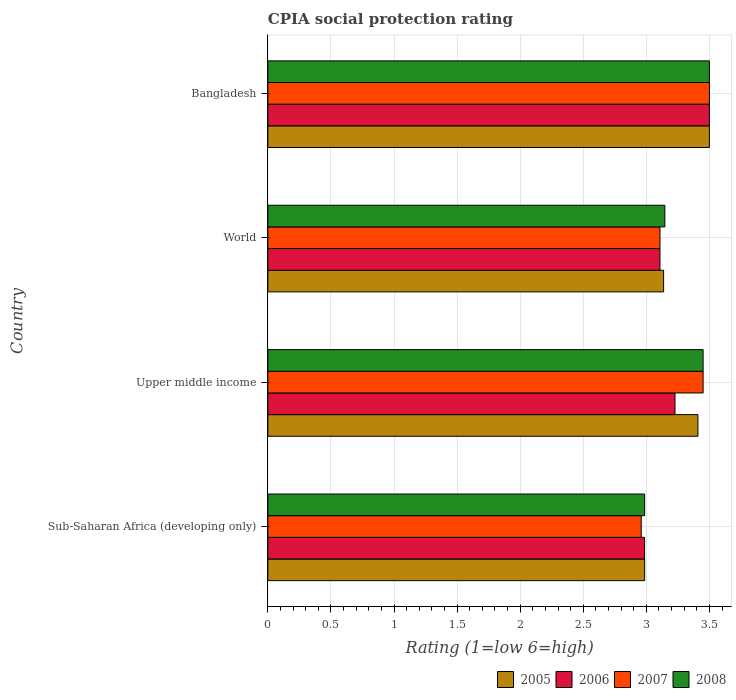How many groups of bars are there?
Provide a succinct answer. 4. Are the number of bars on each tick of the Y-axis equal?
Ensure brevity in your answer.  Yes. What is the label of the 3rd group of bars from the top?
Give a very brief answer. Upper middle income. In how many cases, is the number of bars for a given country not equal to the number of legend labels?
Your answer should be compact. 0. What is the CPIA rating in 2005 in Bangladesh?
Ensure brevity in your answer.  3.5. Across all countries, what is the maximum CPIA rating in 2007?
Your answer should be compact. 3.5. Across all countries, what is the minimum CPIA rating in 2007?
Offer a terse response. 2.96. In which country was the CPIA rating in 2005 minimum?
Give a very brief answer. Sub-Saharan Africa (developing only). What is the total CPIA rating in 2005 in the graph?
Keep it short and to the point. 13.03. What is the difference between the CPIA rating in 2008 in Bangladesh and that in World?
Your answer should be compact. 0.35. What is the difference between the CPIA rating in 2005 in World and the CPIA rating in 2008 in Upper middle income?
Make the answer very short. -0.31. What is the average CPIA rating in 2008 per country?
Offer a very short reply. 3.27. What is the difference between the CPIA rating in 2007 and CPIA rating in 2006 in Upper middle income?
Offer a very short reply. 0.22. What is the ratio of the CPIA rating in 2008 in Bangladesh to that in Upper middle income?
Offer a very short reply. 1.01. Is the CPIA rating in 2008 in Bangladesh less than that in World?
Offer a terse response. No. Is the difference between the CPIA rating in 2007 in Sub-Saharan Africa (developing only) and World greater than the difference between the CPIA rating in 2006 in Sub-Saharan Africa (developing only) and World?
Give a very brief answer. No. What is the difference between the highest and the second highest CPIA rating in 2007?
Your answer should be compact. 0.05. What is the difference between the highest and the lowest CPIA rating in 2005?
Provide a short and direct response. 0.51. Is the sum of the CPIA rating in 2008 in Bangladesh and Upper middle income greater than the maximum CPIA rating in 2006 across all countries?
Offer a very short reply. Yes. Is it the case that in every country, the sum of the CPIA rating in 2005 and CPIA rating in 2006 is greater than the CPIA rating in 2007?
Offer a terse response. Yes. How many bars are there?
Your answer should be very brief. 16. Are all the bars in the graph horizontal?
Ensure brevity in your answer.  Yes. How many countries are there in the graph?
Keep it short and to the point. 4. Does the graph contain grids?
Your answer should be very brief. Yes. Where does the legend appear in the graph?
Keep it short and to the point. Bottom right. How are the legend labels stacked?
Your answer should be compact. Horizontal. What is the title of the graph?
Your answer should be compact. CPIA social protection rating. Does "1997" appear as one of the legend labels in the graph?
Ensure brevity in your answer.  No. What is the Rating (1=low 6=high) in 2005 in Sub-Saharan Africa (developing only)?
Give a very brief answer. 2.99. What is the Rating (1=low 6=high) in 2006 in Sub-Saharan Africa (developing only)?
Keep it short and to the point. 2.99. What is the Rating (1=low 6=high) in 2007 in Sub-Saharan Africa (developing only)?
Offer a very short reply. 2.96. What is the Rating (1=low 6=high) of 2008 in Sub-Saharan Africa (developing only)?
Your answer should be compact. 2.99. What is the Rating (1=low 6=high) in 2005 in Upper middle income?
Ensure brevity in your answer.  3.41. What is the Rating (1=low 6=high) in 2006 in Upper middle income?
Your response must be concise. 3.23. What is the Rating (1=low 6=high) of 2007 in Upper middle income?
Your response must be concise. 3.45. What is the Rating (1=low 6=high) of 2008 in Upper middle income?
Your response must be concise. 3.45. What is the Rating (1=low 6=high) in 2005 in World?
Your response must be concise. 3.14. What is the Rating (1=low 6=high) of 2006 in World?
Keep it short and to the point. 3.11. What is the Rating (1=low 6=high) in 2007 in World?
Make the answer very short. 3.11. What is the Rating (1=low 6=high) in 2008 in World?
Your answer should be compact. 3.15. What is the Rating (1=low 6=high) in 2007 in Bangladesh?
Offer a very short reply. 3.5. What is the Rating (1=low 6=high) in 2008 in Bangladesh?
Give a very brief answer. 3.5. Across all countries, what is the maximum Rating (1=low 6=high) in 2006?
Make the answer very short. 3.5. Across all countries, what is the maximum Rating (1=low 6=high) of 2008?
Provide a succinct answer. 3.5. Across all countries, what is the minimum Rating (1=low 6=high) in 2005?
Your response must be concise. 2.99. Across all countries, what is the minimum Rating (1=low 6=high) in 2006?
Offer a terse response. 2.99. Across all countries, what is the minimum Rating (1=low 6=high) in 2007?
Offer a terse response. 2.96. Across all countries, what is the minimum Rating (1=low 6=high) in 2008?
Offer a very short reply. 2.99. What is the total Rating (1=low 6=high) of 2005 in the graph?
Your answer should be very brief. 13.03. What is the total Rating (1=low 6=high) in 2006 in the graph?
Ensure brevity in your answer.  12.82. What is the total Rating (1=low 6=high) in 2007 in the graph?
Ensure brevity in your answer.  13.02. What is the total Rating (1=low 6=high) in 2008 in the graph?
Offer a terse response. 13.08. What is the difference between the Rating (1=low 6=high) of 2005 in Sub-Saharan Africa (developing only) and that in Upper middle income?
Ensure brevity in your answer.  -0.42. What is the difference between the Rating (1=low 6=high) of 2006 in Sub-Saharan Africa (developing only) and that in Upper middle income?
Provide a succinct answer. -0.24. What is the difference between the Rating (1=low 6=high) of 2007 in Sub-Saharan Africa (developing only) and that in Upper middle income?
Your answer should be very brief. -0.49. What is the difference between the Rating (1=low 6=high) in 2008 in Sub-Saharan Africa (developing only) and that in Upper middle income?
Ensure brevity in your answer.  -0.46. What is the difference between the Rating (1=low 6=high) in 2005 in Sub-Saharan Africa (developing only) and that in World?
Make the answer very short. -0.15. What is the difference between the Rating (1=low 6=high) in 2006 in Sub-Saharan Africa (developing only) and that in World?
Your response must be concise. -0.12. What is the difference between the Rating (1=low 6=high) of 2007 in Sub-Saharan Africa (developing only) and that in World?
Offer a terse response. -0.15. What is the difference between the Rating (1=low 6=high) in 2008 in Sub-Saharan Africa (developing only) and that in World?
Ensure brevity in your answer.  -0.16. What is the difference between the Rating (1=low 6=high) in 2005 in Sub-Saharan Africa (developing only) and that in Bangladesh?
Keep it short and to the point. -0.51. What is the difference between the Rating (1=low 6=high) in 2006 in Sub-Saharan Africa (developing only) and that in Bangladesh?
Ensure brevity in your answer.  -0.51. What is the difference between the Rating (1=low 6=high) of 2007 in Sub-Saharan Africa (developing only) and that in Bangladesh?
Ensure brevity in your answer.  -0.54. What is the difference between the Rating (1=low 6=high) in 2008 in Sub-Saharan Africa (developing only) and that in Bangladesh?
Give a very brief answer. -0.51. What is the difference between the Rating (1=low 6=high) in 2005 in Upper middle income and that in World?
Provide a short and direct response. 0.27. What is the difference between the Rating (1=low 6=high) in 2006 in Upper middle income and that in World?
Offer a very short reply. 0.12. What is the difference between the Rating (1=low 6=high) in 2007 in Upper middle income and that in World?
Offer a terse response. 0.34. What is the difference between the Rating (1=low 6=high) of 2008 in Upper middle income and that in World?
Make the answer very short. 0.3. What is the difference between the Rating (1=low 6=high) in 2005 in Upper middle income and that in Bangladesh?
Your answer should be compact. -0.09. What is the difference between the Rating (1=low 6=high) in 2006 in Upper middle income and that in Bangladesh?
Provide a succinct answer. -0.27. What is the difference between the Rating (1=low 6=high) of 2007 in Upper middle income and that in Bangladesh?
Provide a short and direct response. -0.05. What is the difference between the Rating (1=low 6=high) of 2008 in Upper middle income and that in Bangladesh?
Offer a terse response. -0.05. What is the difference between the Rating (1=low 6=high) of 2005 in World and that in Bangladesh?
Your answer should be compact. -0.36. What is the difference between the Rating (1=low 6=high) in 2006 in World and that in Bangladesh?
Make the answer very short. -0.39. What is the difference between the Rating (1=low 6=high) in 2007 in World and that in Bangladesh?
Your answer should be very brief. -0.39. What is the difference between the Rating (1=low 6=high) in 2008 in World and that in Bangladesh?
Your answer should be compact. -0.35. What is the difference between the Rating (1=low 6=high) in 2005 in Sub-Saharan Africa (developing only) and the Rating (1=low 6=high) in 2006 in Upper middle income?
Ensure brevity in your answer.  -0.24. What is the difference between the Rating (1=low 6=high) in 2005 in Sub-Saharan Africa (developing only) and the Rating (1=low 6=high) in 2007 in Upper middle income?
Your answer should be compact. -0.46. What is the difference between the Rating (1=low 6=high) of 2005 in Sub-Saharan Africa (developing only) and the Rating (1=low 6=high) of 2008 in Upper middle income?
Ensure brevity in your answer.  -0.46. What is the difference between the Rating (1=low 6=high) of 2006 in Sub-Saharan Africa (developing only) and the Rating (1=low 6=high) of 2007 in Upper middle income?
Give a very brief answer. -0.46. What is the difference between the Rating (1=low 6=high) of 2006 in Sub-Saharan Africa (developing only) and the Rating (1=low 6=high) of 2008 in Upper middle income?
Ensure brevity in your answer.  -0.46. What is the difference between the Rating (1=low 6=high) in 2007 in Sub-Saharan Africa (developing only) and the Rating (1=low 6=high) in 2008 in Upper middle income?
Give a very brief answer. -0.49. What is the difference between the Rating (1=low 6=high) of 2005 in Sub-Saharan Africa (developing only) and the Rating (1=low 6=high) of 2006 in World?
Your response must be concise. -0.12. What is the difference between the Rating (1=low 6=high) of 2005 in Sub-Saharan Africa (developing only) and the Rating (1=low 6=high) of 2007 in World?
Keep it short and to the point. -0.12. What is the difference between the Rating (1=low 6=high) of 2005 in Sub-Saharan Africa (developing only) and the Rating (1=low 6=high) of 2008 in World?
Provide a succinct answer. -0.16. What is the difference between the Rating (1=low 6=high) of 2006 in Sub-Saharan Africa (developing only) and the Rating (1=low 6=high) of 2007 in World?
Your response must be concise. -0.12. What is the difference between the Rating (1=low 6=high) of 2006 in Sub-Saharan Africa (developing only) and the Rating (1=low 6=high) of 2008 in World?
Keep it short and to the point. -0.16. What is the difference between the Rating (1=low 6=high) of 2007 in Sub-Saharan Africa (developing only) and the Rating (1=low 6=high) of 2008 in World?
Keep it short and to the point. -0.19. What is the difference between the Rating (1=low 6=high) of 2005 in Sub-Saharan Africa (developing only) and the Rating (1=low 6=high) of 2006 in Bangladesh?
Keep it short and to the point. -0.51. What is the difference between the Rating (1=low 6=high) in 2005 in Sub-Saharan Africa (developing only) and the Rating (1=low 6=high) in 2007 in Bangladesh?
Give a very brief answer. -0.51. What is the difference between the Rating (1=low 6=high) in 2005 in Sub-Saharan Africa (developing only) and the Rating (1=low 6=high) in 2008 in Bangladesh?
Your response must be concise. -0.51. What is the difference between the Rating (1=low 6=high) in 2006 in Sub-Saharan Africa (developing only) and the Rating (1=low 6=high) in 2007 in Bangladesh?
Your answer should be compact. -0.51. What is the difference between the Rating (1=low 6=high) in 2006 in Sub-Saharan Africa (developing only) and the Rating (1=low 6=high) in 2008 in Bangladesh?
Keep it short and to the point. -0.51. What is the difference between the Rating (1=low 6=high) in 2007 in Sub-Saharan Africa (developing only) and the Rating (1=low 6=high) in 2008 in Bangladesh?
Keep it short and to the point. -0.54. What is the difference between the Rating (1=low 6=high) of 2005 in Upper middle income and the Rating (1=low 6=high) of 2006 in World?
Ensure brevity in your answer.  0.3. What is the difference between the Rating (1=low 6=high) of 2005 in Upper middle income and the Rating (1=low 6=high) of 2007 in World?
Your answer should be compact. 0.3. What is the difference between the Rating (1=low 6=high) in 2005 in Upper middle income and the Rating (1=low 6=high) in 2008 in World?
Provide a succinct answer. 0.26. What is the difference between the Rating (1=low 6=high) in 2006 in Upper middle income and the Rating (1=low 6=high) in 2007 in World?
Ensure brevity in your answer.  0.12. What is the difference between the Rating (1=low 6=high) of 2006 in Upper middle income and the Rating (1=low 6=high) of 2008 in World?
Make the answer very short. 0.08. What is the difference between the Rating (1=low 6=high) in 2007 in Upper middle income and the Rating (1=low 6=high) in 2008 in World?
Your answer should be compact. 0.3. What is the difference between the Rating (1=low 6=high) in 2005 in Upper middle income and the Rating (1=low 6=high) in 2006 in Bangladesh?
Your response must be concise. -0.09. What is the difference between the Rating (1=low 6=high) of 2005 in Upper middle income and the Rating (1=low 6=high) of 2007 in Bangladesh?
Your answer should be compact. -0.09. What is the difference between the Rating (1=low 6=high) of 2005 in Upper middle income and the Rating (1=low 6=high) of 2008 in Bangladesh?
Keep it short and to the point. -0.09. What is the difference between the Rating (1=low 6=high) of 2006 in Upper middle income and the Rating (1=low 6=high) of 2007 in Bangladesh?
Keep it short and to the point. -0.27. What is the difference between the Rating (1=low 6=high) in 2006 in Upper middle income and the Rating (1=low 6=high) in 2008 in Bangladesh?
Your answer should be compact. -0.27. What is the difference between the Rating (1=low 6=high) in 2007 in Upper middle income and the Rating (1=low 6=high) in 2008 in Bangladesh?
Your answer should be compact. -0.05. What is the difference between the Rating (1=low 6=high) of 2005 in World and the Rating (1=low 6=high) of 2006 in Bangladesh?
Your answer should be very brief. -0.36. What is the difference between the Rating (1=low 6=high) in 2005 in World and the Rating (1=low 6=high) in 2007 in Bangladesh?
Provide a short and direct response. -0.36. What is the difference between the Rating (1=low 6=high) in 2005 in World and the Rating (1=low 6=high) in 2008 in Bangladesh?
Provide a short and direct response. -0.36. What is the difference between the Rating (1=low 6=high) of 2006 in World and the Rating (1=low 6=high) of 2007 in Bangladesh?
Your answer should be compact. -0.39. What is the difference between the Rating (1=low 6=high) of 2006 in World and the Rating (1=low 6=high) of 2008 in Bangladesh?
Give a very brief answer. -0.39. What is the difference between the Rating (1=low 6=high) of 2007 in World and the Rating (1=low 6=high) of 2008 in Bangladesh?
Your response must be concise. -0.39. What is the average Rating (1=low 6=high) in 2005 per country?
Offer a terse response. 3.26. What is the average Rating (1=low 6=high) of 2006 per country?
Offer a terse response. 3.21. What is the average Rating (1=low 6=high) in 2007 per country?
Your answer should be very brief. 3.25. What is the average Rating (1=low 6=high) of 2008 per country?
Provide a succinct answer. 3.27. What is the difference between the Rating (1=low 6=high) in 2005 and Rating (1=low 6=high) in 2007 in Sub-Saharan Africa (developing only)?
Your response must be concise. 0.03. What is the difference between the Rating (1=low 6=high) in 2005 and Rating (1=low 6=high) in 2008 in Sub-Saharan Africa (developing only)?
Keep it short and to the point. 0. What is the difference between the Rating (1=low 6=high) in 2006 and Rating (1=low 6=high) in 2007 in Sub-Saharan Africa (developing only)?
Ensure brevity in your answer.  0.03. What is the difference between the Rating (1=low 6=high) of 2006 and Rating (1=low 6=high) of 2008 in Sub-Saharan Africa (developing only)?
Your answer should be compact. -0. What is the difference between the Rating (1=low 6=high) of 2007 and Rating (1=low 6=high) of 2008 in Sub-Saharan Africa (developing only)?
Keep it short and to the point. -0.03. What is the difference between the Rating (1=low 6=high) of 2005 and Rating (1=low 6=high) of 2006 in Upper middle income?
Ensure brevity in your answer.  0.18. What is the difference between the Rating (1=low 6=high) of 2005 and Rating (1=low 6=high) of 2007 in Upper middle income?
Offer a terse response. -0.04. What is the difference between the Rating (1=low 6=high) of 2005 and Rating (1=low 6=high) of 2008 in Upper middle income?
Make the answer very short. -0.04. What is the difference between the Rating (1=low 6=high) of 2006 and Rating (1=low 6=high) of 2007 in Upper middle income?
Offer a very short reply. -0.22. What is the difference between the Rating (1=low 6=high) of 2006 and Rating (1=low 6=high) of 2008 in Upper middle income?
Make the answer very short. -0.22. What is the difference between the Rating (1=low 6=high) in 2005 and Rating (1=low 6=high) in 2006 in World?
Your answer should be very brief. 0.03. What is the difference between the Rating (1=low 6=high) of 2005 and Rating (1=low 6=high) of 2007 in World?
Your answer should be very brief. 0.03. What is the difference between the Rating (1=low 6=high) in 2005 and Rating (1=low 6=high) in 2008 in World?
Make the answer very short. -0.01. What is the difference between the Rating (1=low 6=high) in 2006 and Rating (1=low 6=high) in 2008 in World?
Your response must be concise. -0.04. What is the difference between the Rating (1=low 6=high) of 2007 and Rating (1=low 6=high) of 2008 in World?
Provide a succinct answer. -0.04. What is the difference between the Rating (1=low 6=high) in 2005 and Rating (1=low 6=high) in 2007 in Bangladesh?
Your answer should be very brief. 0. What is the difference between the Rating (1=low 6=high) of 2006 and Rating (1=low 6=high) of 2008 in Bangladesh?
Your answer should be very brief. 0. What is the difference between the Rating (1=low 6=high) of 2007 and Rating (1=low 6=high) of 2008 in Bangladesh?
Provide a succinct answer. 0. What is the ratio of the Rating (1=low 6=high) of 2005 in Sub-Saharan Africa (developing only) to that in Upper middle income?
Your response must be concise. 0.88. What is the ratio of the Rating (1=low 6=high) in 2006 in Sub-Saharan Africa (developing only) to that in Upper middle income?
Offer a very short reply. 0.93. What is the ratio of the Rating (1=low 6=high) in 2007 in Sub-Saharan Africa (developing only) to that in Upper middle income?
Your answer should be compact. 0.86. What is the ratio of the Rating (1=low 6=high) of 2008 in Sub-Saharan Africa (developing only) to that in Upper middle income?
Provide a short and direct response. 0.87. What is the ratio of the Rating (1=low 6=high) in 2005 in Sub-Saharan Africa (developing only) to that in World?
Offer a very short reply. 0.95. What is the ratio of the Rating (1=low 6=high) of 2006 in Sub-Saharan Africa (developing only) to that in World?
Offer a very short reply. 0.96. What is the ratio of the Rating (1=low 6=high) in 2007 in Sub-Saharan Africa (developing only) to that in World?
Offer a terse response. 0.95. What is the ratio of the Rating (1=low 6=high) of 2008 in Sub-Saharan Africa (developing only) to that in World?
Your answer should be very brief. 0.95. What is the ratio of the Rating (1=low 6=high) of 2005 in Sub-Saharan Africa (developing only) to that in Bangladesh?
Provide a short and direct response. 0.85. What is the ratio of the Rating (1=low 6=high) of 2006 in Sub-Saharan Africa (developing only) to that in Bangladesh?
Give a very brief answer. 0.85. What is the ratio of the Rating (1=low 6=high) in 2007 in Sub-Saharan Africa (developing only) to that in Bangladesh?
Provide a succinct answer. 0.85. What is the ratio of the Rating (1=low 6=high) in 2008 in Sub-Saharan Africa (developing only) to that in Bangladesh?
Your response must be concise. 0.85. What is the ratio of the Rating (1=low 6=high) in 2005 in Upper middle income to that in World?
Give a very brief answer. 1.09. What is the ratio of the Rating (1=low 6=high) in 2006 in Upper middle income to that in World?
Give a very brief answer. 1.04. What is the ratio of the Rating (1=low 6=high) of 2007 in Upper middle income to that in World?
Make the answer very short. 1.11. What is the ratio of the Rating (1=low 6=high) of 2008 in Upper middle income to that in World?
Ensure brevity in your answer.  1.1. What is the ratio of the Rating (1=low 6=high) in 2005 in Upper middle income to that in Bangladesh?
Provide a short and direct response. 0.97. What is the ratio of the Rating (1=low 6=high) in 2006 in Upper middle income to that in Bangladesh?
Provide a succinct answer. 0.92. What is the ratio of the Rating (1=low 6=high) of 2007 in Upper middle income to that in Bangladesh?
Keep it short and to the point. 0.99. What is the ratio of the Rating (1=low 6=high) in 2008 in Upper middle income to that in Bangladesh?
Provide a succinct answer. 0.99. What is the ratio of the Rating (1=low 6=high) of 2005 in World to that in Bangladesh?
Offer a terse response. 0.9. What is the ratio of the Rating (1=low 6=high) in 2006 in World to that in Bangladesh?
Give a very brief answer. 0.89. What is the ratio of the Rating (1=low 6=high) of 2007 in World to that in Bangladesh?
Offer a terse response. 0.89. What is the ratio of the Rating (1=low 6=high) of 2008 in World to that in Bangladesh?
Make the answer very short. 0.9. What is the difference between the highest and the second highest Rating (1=low 6=high) in 2005?
Make the answer very short. 0.09. What is the difference between the highest and the second highest Rating (1=low 6=high) in 2006?
Your answer should be compact. 0.27. What is the difference between the highest and the lowest Rating (1=low 6=high) of 2005?
Give a very brief answer. 0.51. What is the difference between the highest and the lowest Rating (1=low 6=high) of 2006?
Ensure brevity in your answer.  0.51. What is the difference between the highest and the lowest Rating (1=low 6=high) of 2007?
Ensure brevity in your answer.  0.54. What is the difference between the highest and the lowest Rating (1=low 6=high) in 2008?
Keep it short and to the point. 0.51. 